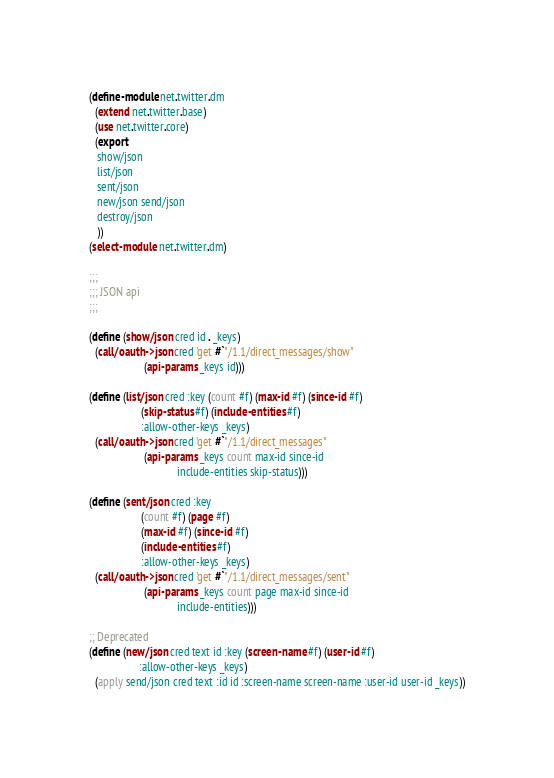<code> <loc_0><loc_0><loc_500><loc_500><_Scheme_>(define-module net.twitter.dm
  (extend net.twitter.base)
  (use net.twitter.core)
  (export
   show/json
   list/json
   sent/json
   new/json send/json
   destroy/json
   ))
(select-module net.twitter.dm)

;;;
;;; JSON api
;;;

(define (show/json cred id . _keys)
  (call/oauth->json cred 'get #`"/1.1/direct_messages/show"
                    (api-params _keys id)))

(define (list/json cred :key (count #f) (max-id #f) (since-id #f)
                   (skip-status #f) (include-entities #f)
                   :allow-other-keys _keys)
  (call/oauth->json cred 'get #`"/1.1/direct_messages"
                    (api-params _keys count max-id since-id
                                include-entities skip-status)))

(define (sent/json cred :key
                   (count #f) (page #f)
                   (max-id #f) (since-id #f)
                   (include-entities #f)
                   :allow-other-keys _keys)
  (call/oauth->json cred 'get #`"/1.1/direct_messages/sent"
                    (api-params _keys count page max-id since-id
                                include-entities)))

;; Deprecated
(define (new/json cred text id :key (screen-name #f) (user-id #f)
                  :allow-other-keys _keys)
  (apply send/json cred text :id id :screen-name screen-name :user-id user-id _keys))
</code> 